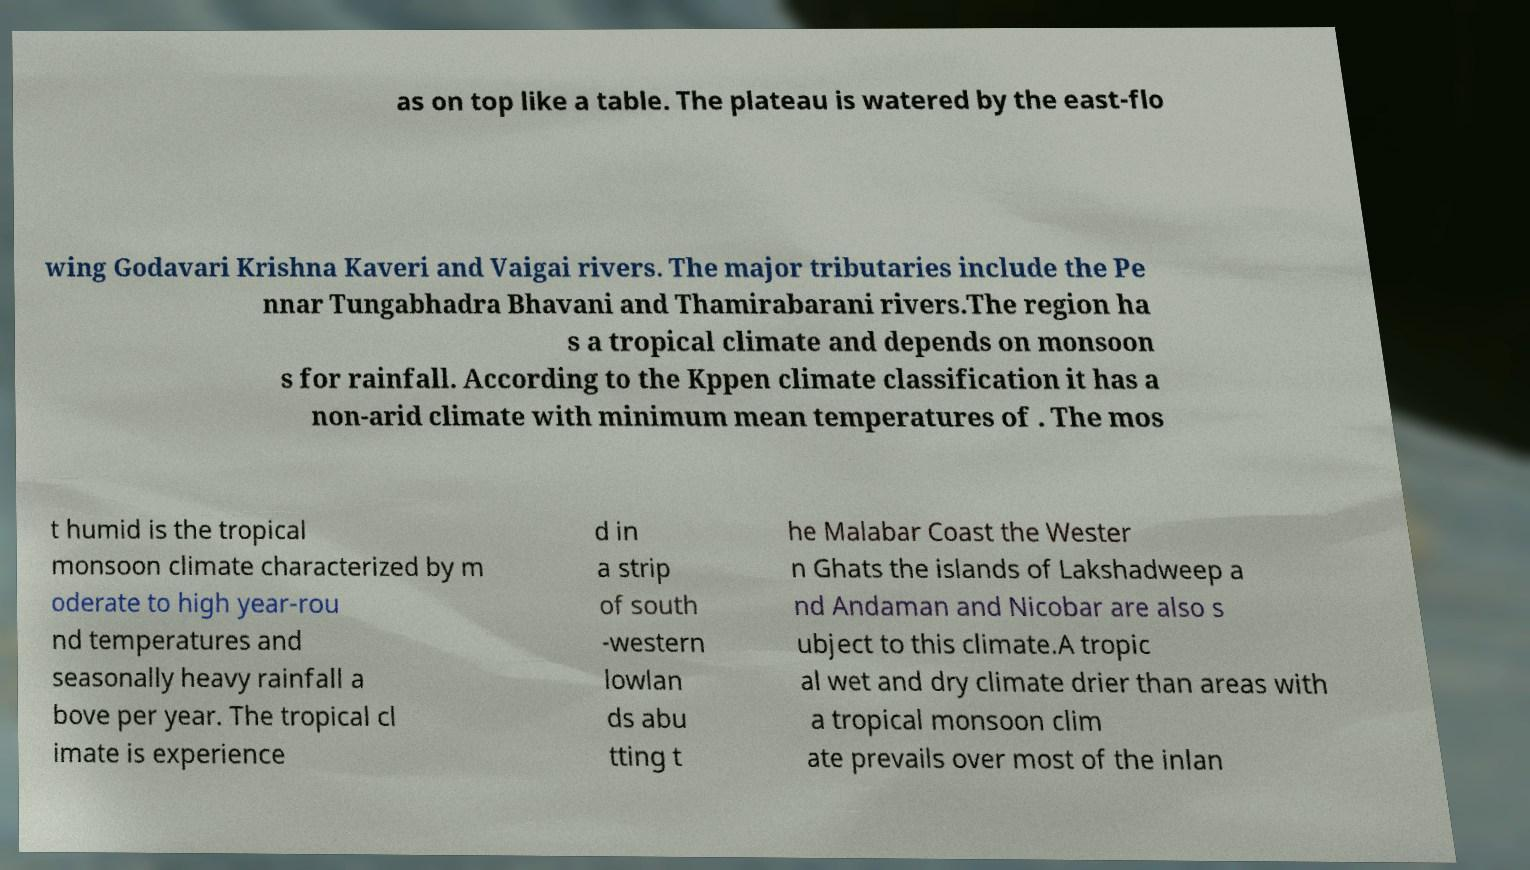Please identify and transcribe the text found in this image. as on top like a table. The plateau is watered by the east-flo wing Godavari Krishna Kaveri and Vaigai rivers. The major tributaries include the Pe nnar Tungabhadra Bhavani and Thamirabarani rivers.The region ha s a tropical climate and depends on monsoon s for rainfall. According to the Kppen climate classification it has a non-arid climate with minimum mean temperatures of . The mos t humid is the tropical monsoon climate characterized by m oderate to high year-rou nd temperatures and seasonally heavy rainfall a bove per year. The tropical cl imate is experience d in a strip of south -western lowlan ds abu tting t he Malabar Coast the Wester n Ghats the islands of Lakshadweep a nd Andaman and Nicobar are also s ubject to this climate.A tropic al wet and dry climate drier than areas with a tropical monsoon clim ate prevails over most of the inlan 